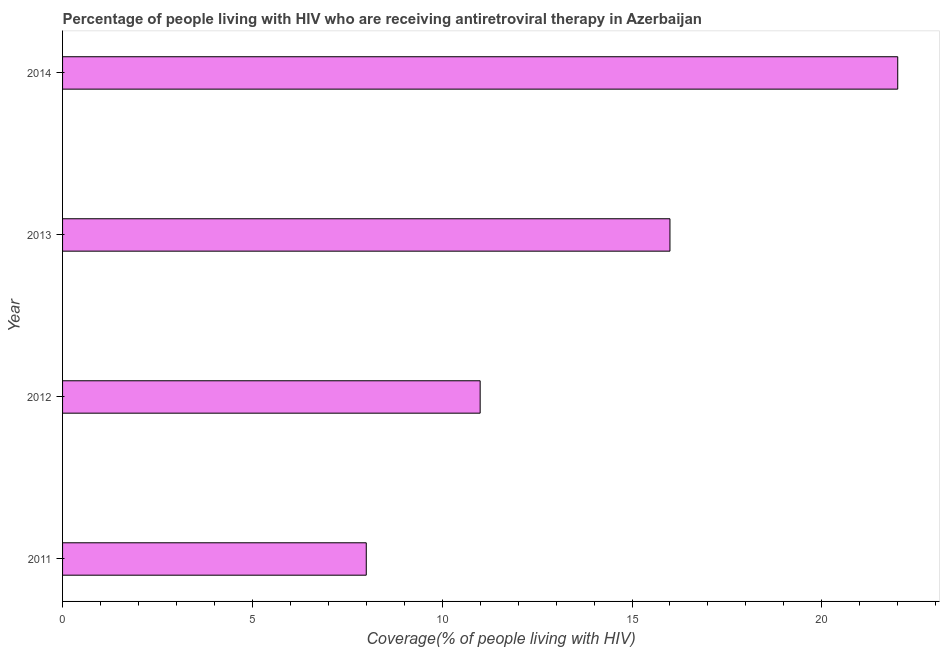Does the graph contain any zero values?
Provide a short and direct response. No. What is the title of the graph?
Your response must be concise. Percentage of people living with HIV who are receiving antiretroviral therapy in Azerbaijan. What is the label or title of the X-axis?
Your answer should be compact. Coverage(% of people living with HIV). What is the antiretroviral therapy coverage in 2014?
Your answer should be compact. 22. Across all years, what is the maximum antiretroviral therapy coverage?
Provide a short and direct response. 22. Across all years, what is the minimum antiretroviral therapy coverage?
Keep it short and to the point. 8. In which year was the antiretroviral therapy coverage minimum?
Offer a very short reply. 2011. What is the ratio of the antiretroviral therapy coverage in 2011 to that in 2014?
Offer a terse response. 0.36. What is the difference between the highest and the lowest antiretroviral therapy coverage?
Ensure brevity in your answer.  14. How many bars are there?
Keep it short and to the point. 4. Are the values on the major ticks of X-axis written in scientific E-notation?
Keep it short and to the point. No. What is the Coverage(% of people living with HIV) in 2012?
Your answer should be very brief. 11. What is the Coverage(% of people living with HIV) in 2013?
Make the answer very short. 16. What is the difference between the Coverage(% of people living with HIV) in 2012 and 2014?
Ensure brevity in your answer.  -11. What is the difference between the Coverage(% of people living with HIV) in 2013 and 2014?
Your answer should be compact. -6. What is the ratio of the Coverage(% of people living with HIV) in 2011 to that in 2012?
Make the answer very short. 0.73. What is the ratio of the Coverage(% of people living with HIV) in 2011 to that in 2013?
Provide a succinct answer. 0.5. What is the ratio of the Coverage(% of people living with HIV) in 2011 to that in 2014?
Provide a succinct answer. 0.36. What is the ratio of the Coverage(% of people living with HIV) in 2012 to that in 2013?
Offer a terse response. 0.69. What is the ratio of the Coverage(% of people living with HIV) in 2013 to that in 2014?
Give a very brief answer. 0.73. 